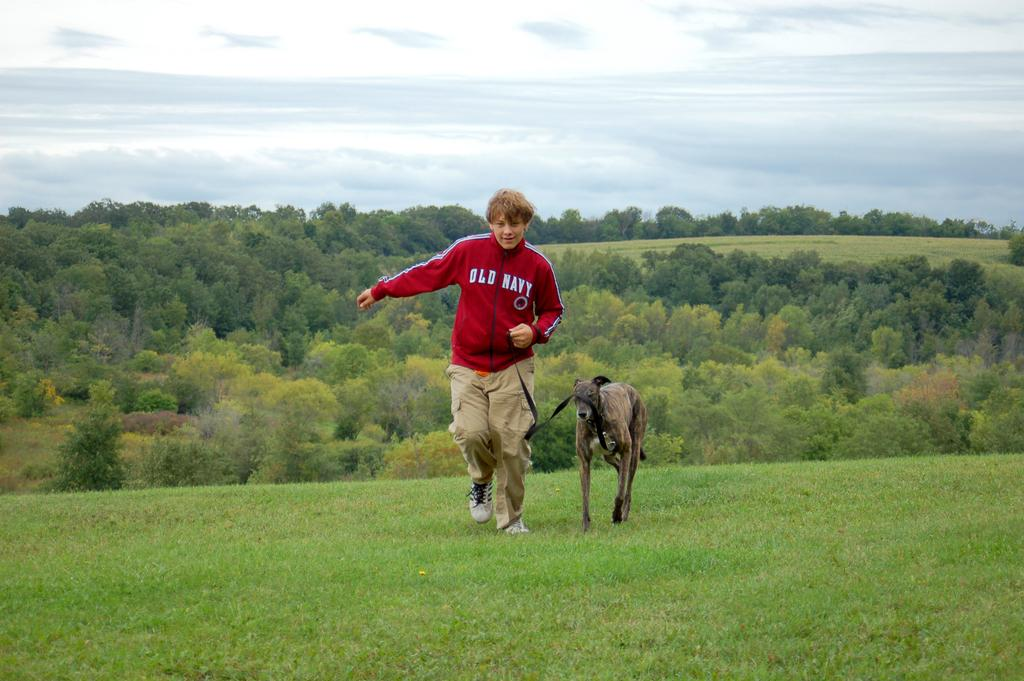Who is the main subject in the picture? There is a boy in the picture. What is the boy holding in the image? The boy is holding a belt of an animal. What is the boy doing in the picture? The boy is running on the grass. What can be seen in the background of the image? There are trees visible in the background. What shape is the airplane flying in the background of the image? There is no airplane present in the image; it only features a boy running on the grass with trees in the background. 